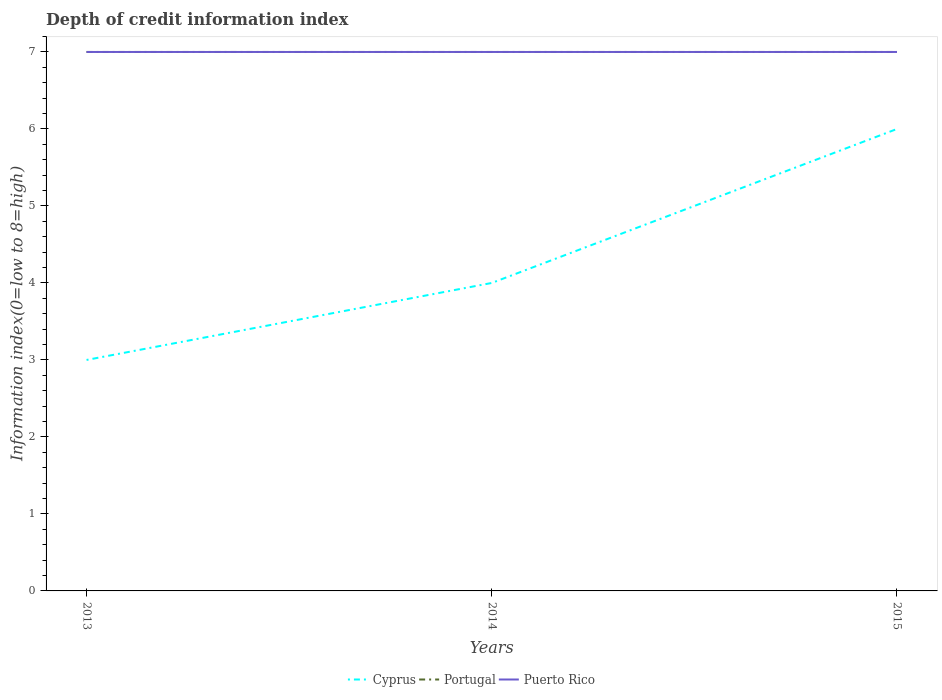How many different coloured lines are there?
Ensure brevity in your answer.  3. Is the number of lines equal to the number of legend labels?
Offer a terse response. Yes. Across all years, what is the maximum information index in Cyprus?
Offer a very short reply. 3. In which year was the information index in Cyprus maximum?
Ensure brevity in your answer.  2013. What is the difference between the highest and the second highest information index in Cyprus?
Give a very brief answer. 3. Is the information index in Cyprus strictly greater than the information index in Portugal over the years?
Your answer should be very brief. Yes. What is the difference between two consecutive major ticks on the Y-axis?
Your answer should be very brief. 1. Does the graph contain grids?
Offer a terse response. No. Where does the legend appear in the graph?
Keep it short and to the point. Bottom center. How are the legend labels stacked?
Ensure brevity in your answer.  Horizontal. What is the title of the graph?
Keep it short and to the point. Depth of credit information index. What is the label or title of the X-axis?
Your answer should be very brief. Years. What is the label or title of the Y-axis?
Your response must be concise. Information index(0=low to 8=high). What is the Information index(0=low to 8=high) of Portugal in 2013?
Your response must be concise. 7. What is the Information index(0=low to 8=high) in Puerto Rico in 2013?
Keep it short and to the point. 7. What is the Information index(0=low to 8=high) of Cyprus in 2014?
Your response must be concise. 4. What is the Information index(0=low to 8=high) of Portugal in 2014?
Give a very brief answer. 7. What is the Information index(0=low to 8=high) in Puerto Rico in 2014?
Offer a very short reply. 7. What is the Information index(0=low to 8=high) in Cyprus in 2015?
Ensure brevity in your answer.  6. Across all years, what is the maximum Information index(0=low to 8=high) in Cyprus?
Offer a terse response. 6. Across all years, what is the minimum Information index(0=low to 8=high) of Portugal?
Offer a terse response. 7. What is the total Information index(0=low to 8=high) of Cyprus in the graph?
Offer a very short reply. 13. What is the total Information index(0=low to 8=high) in Puerto Rico in the graph?
Make the answer very short. 21. What is the difference between the Information index(0=low to 8=high) of Cyprus in 2013 and that in 2014?
Make the answer very short. -1. What is the difference between the Information index(0=low to 8=high) in Portugal in 2013 and that in 2014?
Your answer should be compact. 0. What is the difference between the Information index(0=low to 8=high) of Puerto Rico in 2013 and that in 2014?
Provide a succinct answer. 0. What is the difference between the Information index(0=low to 8=high) of Puerto Rico in 2013 and that in 2015?
Offer a terse response. 0. What is the difference between the Information index(0=low to 8=high) in Cyprus in 2014 and that in 2015?
Make the answer very short. -2. What is the difference between the Information index(0=low to 8=high) in Portugal in 2014 and that in 2015?
Ensure brevity in your answer.  0. What is the difference between the Information index(0=low to 8=high) of Cyprus in 2013 and the Information index(0=low to 8=high) of Portugal in 2014?
Provide a short and direct response. -4. What is the difference between the Information index(0=low to 8=high) of Cyprus in 2013 and the Information index(0=low to 8=high) of Portugal in 2015?
Provide a short and direct response. -4. What is the difference between the Information index(0=low to 8=high) in Portugal in 2013 and the Information index(0=low to 8=high) in Puerto Rico in 2015?
Offer a terse response. 0. What is the difference between the Information index(0=low to 8=high) of Cyprus in 2014 and the Information index(0=low to 8=high) of Portugal in 2015?
Offer a terse response. -3. What is the average Information index(0=low to 8=high) in Cyprus per year?
Your answer should be compact. 4.33. In the year 2013, what is the difference between the Information index(0=low to 8=high) of Cyprus and Information index(0=low to 8=high) of Puerto Rico?
Offer a terse response. -4. In the year 2013, what is the difference between the Information index(0=low to 8=high) of Portugal and Information index(0=low to 8=high) of Puerto Rico?
Your answer should be compact. 0. In the year 2014, what is the difference between the Information index(0=low to 8=high) of Cyprus and Information index(0=low to 8=high) of Portugal?
Ensure brevity in your answer.  -3. In the year 2014, what is the difference between the Information index(0=low to 8=high) in Cyprus and Information index(0=low to 8=high) in Puerto Rico?
Your answer should be compact. -3. In the year 2014, what is the difference between the Information index(0=low to 8=high) in Portugal and Information index(0=low to 8=high) in Puerto Rico?
Your answer should be compact. 0. In the year 2015, what is the difference between the Information index(0=low to 8=high) in Portugal and Information index(0=low to 8=high) in Puerto Rico?
Your answer should be very brief. 0. What is the ratio of the Information index(0=low to 8=high) of Cyprus in 2013 to that in 2014?
Keep it short and to the point. 0.75. What is the ratio of the Information index(0=low to 8=high) of Cyprus in 2014 to that in 2015?
Make the answer very short. 0.67. What is the ratio of the Information index(0=low to 8=high) in Portugal in 2014 to that in 2015?
Keep it short and to the point. 1. What is the ratio of the Information index(0=low to 8=high) in Puerto Rico in 2014 to that in 2015?
Provide a succinct answer. 1. What is the difference between the highest and the second highest Information index(0=low to 8=high) in Cyprus?
Your answer should be very brief. 2. What is the difference between the highest and the second highest Information index(0=low to 8=high) in Portugal?
Your answer should be very brief. 0. What is the difference between the highest and the second highest Information index(0=low to 8=high) of Puerto Rico?
Your answer should be very brief. 0. What is the difference between the highest and the lowest Information index(0=low to 8=high) in Cyprus?
Provide a short and direct response. 3. What is the difference between the highest and the lowest Information index(0=low to 8=high) of Puerto Rico?
Your response must be concise. 0. 